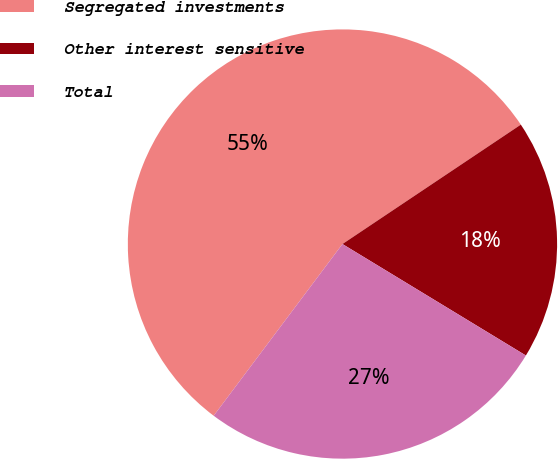Convert chart. <chart><loc_0><loc_0><loc_500><loc_500><pie_chart><fcel>Segregated investments<fcel>Other interest sensitive<fcel>Total<nl><fcel>55.37%<fcel>18.08%<fcel>26.55%<nl></chart> 